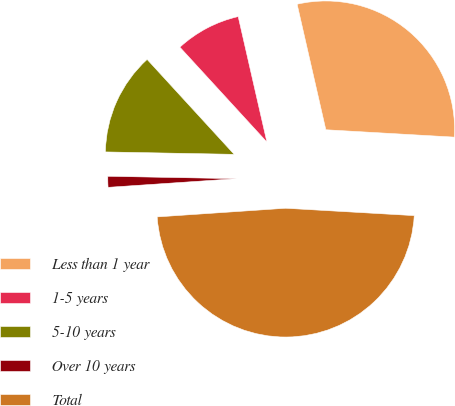<chart> <loc_0><loc_0><loc_500><loc_500><pie_chart><fcel>Less than 1 year<fcel>1-5 years<fcel>5-10 years<fcel>Over 10 years<fcel>Total<nl><fcel>29.49%<fcel>8.23%<fcel>12.89%<fcel>1.37%<fcel>48.01%<nl></chart> 